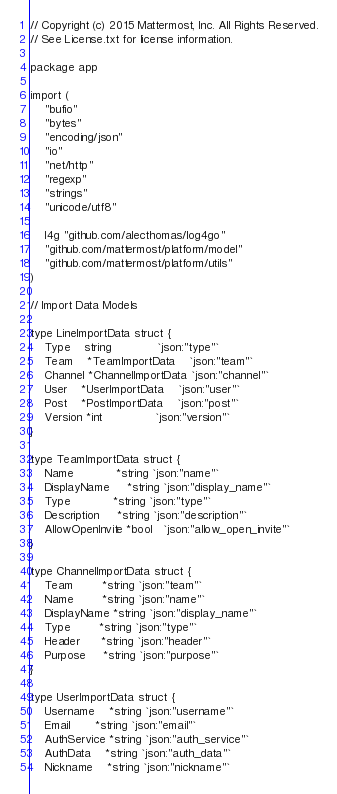<code> <loc_0><loc_0><loc_500><loc_500><_Go_>// Copyright (c) 2015 Mattermost, Inc. All Rights Reserved.
// See License.txt for license information.

package app

import (
	"bufio"
	"bytes"
	"encoding/json"
	"io"
	"net/http"
	"regexp"
	"strings"
	"unicode/utf8"

	l4g "github.com/alecthomas/log4go"
	"github.com/mattermost/platform/model"
	"github.com/mattermost/platform/utils"
)

// Import Data Models

type LineImportData struct {
	Type    string             `json:"type"`
	Team    *TeamImportData    `json:"team"`
	Channel *ChannelImportData `json:"channel"`
	User    *UserImportData    `json:"user"`
	Post    *PostImportData    `json:"post"`
	Version *int               `json:"version"`
}

type TeamImportData struct {
	Name            *string `json:"name"`
	DisplayName     *string `json:"display_name"`
	Type            *string `json:"type"`
	Description     *string `json:"description"`
	AllowOpenInvite *bool   `json:"allow_open_invite"`
}

type ChannelImportData struct {
	Team        *string `json:"team"`
	Name        *string `json:"name"`
	DisplayName *string `json:"display_name"`
	Type        *string `json:"type"`
	Header      *string `json:"header"`
	Purpose     *string `json:"purpose"`
}

type UserImportData struct {
	Username    *string `json:"username"`
	Email       *string `json:"email"`
	AuthService *string `json:"auth_service"`
	AuthData    *string `json:"auth_data"`
	Nickname    *string `json:"nickname"`</code> 